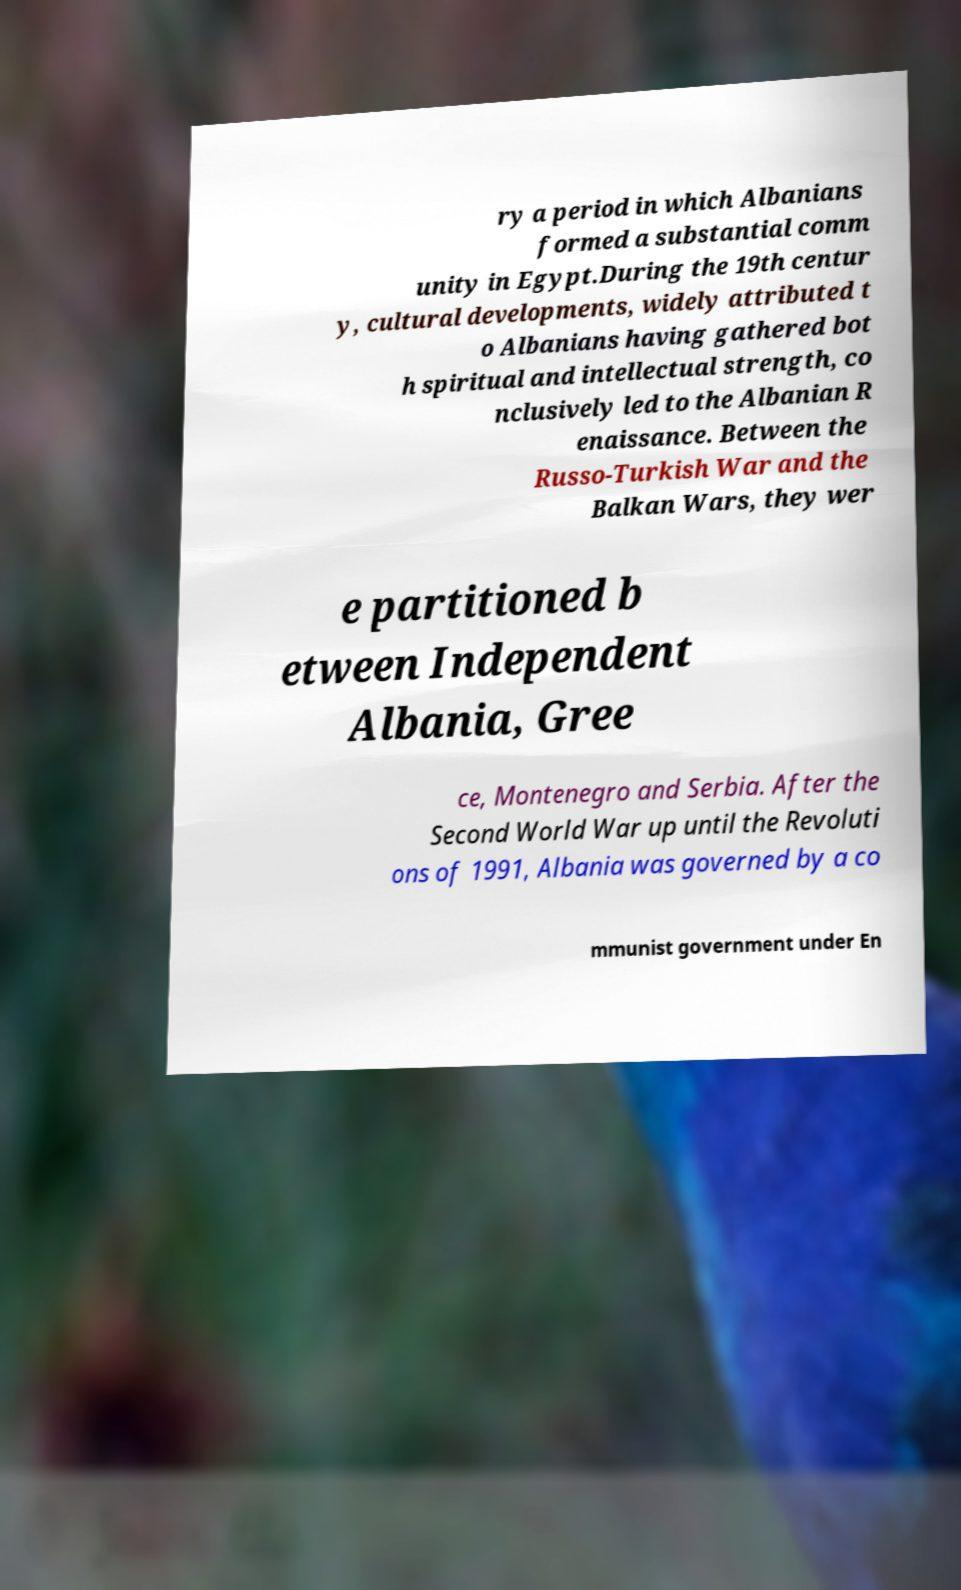There's text embedded in this image that I need extracted. Can you transcribe it verbatim? ry a period in which Albanians formed a substantial comm unity in Egypt.During the 19th centur y, cultural developments, widely attributed t o Albanians having gathered bot h spiritual and intellectual strength, co nclusively led to the Albanian R enaissance. Between the Russo-Turkish War and the Balkan Wars, they wer e partitioned b etween Independent Albania, Gree ce, Montenegro and Serbia. After the Second World War up until the Revoluti ons of 1991, Albania was governed by a co mmunist government under En 